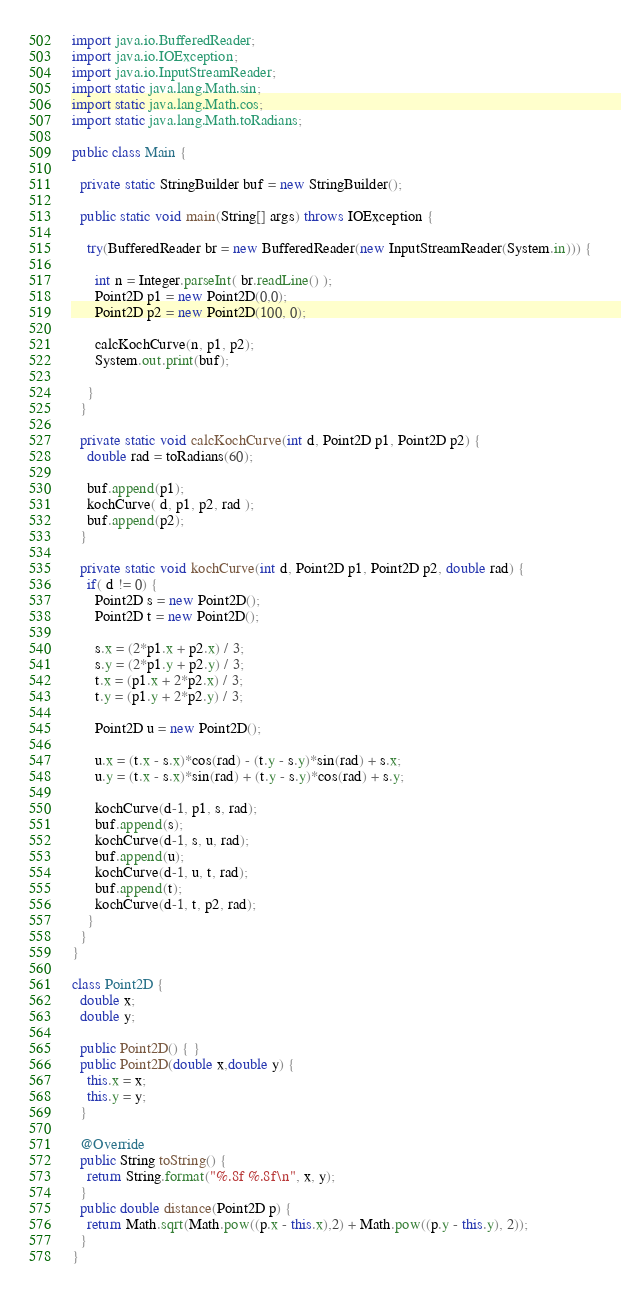<code> <loc_0><loc_0><loc_500><loc_500><_Java_>import java.io.BufferedReader;
import java.io.IOException;
import java.io.InputStreamReader;
import static java.lang.Math.sin;
import static java.lang.Math.cos;
import static java.lang.Math.toRadians;

public class Main {

  private static StringBuilder buf = new StringBuilder();

  public static void main(String[] args) throws IOException {
    
    try(BufferedReader br = new BufferedReader(new InputStreamReader(System.in))) {

      int n = Integer.parseInt( br.readLine() );
      Point2D p1 = new Point2D(0,0);
      Point2D p2 = new Point2D(100, 0);

      calcKochCurve(n, p1, p2);
      System.out.print(buf);
      
    }
  }

  private static void calcKochCurve(int d, Point2D p1, Point2D p2) {
    double rad = toRadians(60);

    buf.append(p1);
    kochCurve( d, p1, p2, rad );
    buf.append(p2);
  } 

  private static void kochCurve(int d, Point2D p1, Point2D p2, double rad) {
    if( d != 0) {
      Point2D s = new Point2D();
      Point2D t = new Point2D();

      s.x = (2*p1.x + p2.x) / 3;
      s.y = (2*p1.y + p2.y) / 3;
      t.x = (p1.x + 2*p2.x) / 3;
      t.y = (p1.y + 2*p2.y) / 3;

      Point2D u = new Point2D();

      u.x = (t.x - s.x)*cos(rad) - (t.y - s.y)*sin(rad) + s.x;
      u.y = (t.x - s.x)*sin(rad) + (t.y - s.y)*cos(rad) + s.y;

      kochCurve(d-1, p1, s, rad);
      buf.append(s);
      kochCurve(d-1, s, u, rad);
      buf.append(u);
      kochCurve(d-1, u, t, rad);
      buf.append(t);
      kochCurve(d-1, t, p2, rad);
    }
  }
}

class Point2D {
  double x;
  double y;

  public Point2D() { }
  public Point2D(double x,double y) {
    this.x = x;
    this.y = y;
  }

  @Override
  public String toString() {
    return String.format("%.8f %.8f\n", x, y);
  }
  public double distance(Point2D p) {
    return Math.sqrt(Math.pow((p.x - this.x),2) + Math.pow((p.y - this.y), 2));
  }
}
</code> 